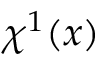<formula> <loc_0><loc_0><loc_500><loc_500>\chi ^ { 1 } ( x )</formula> 